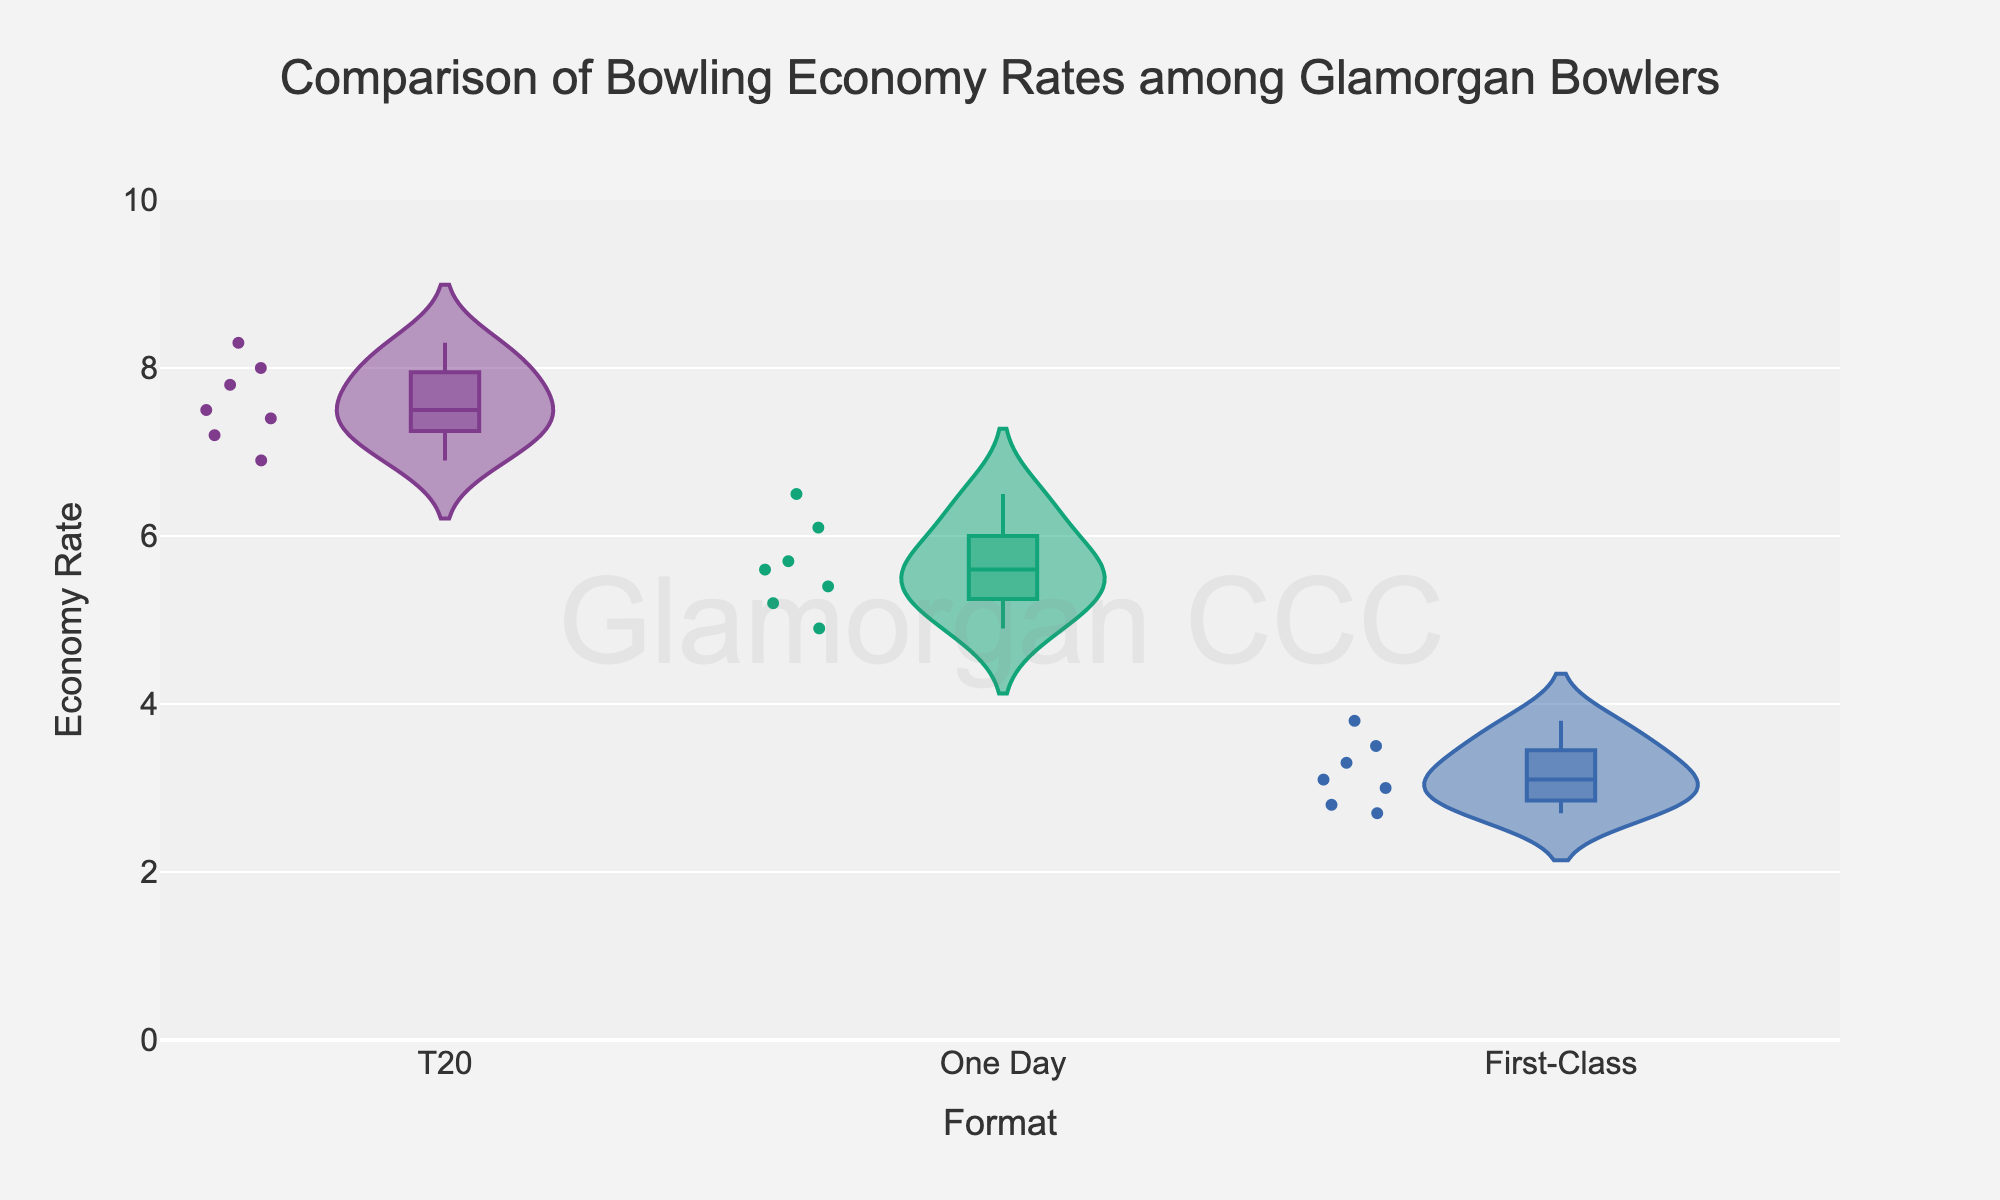Which formats are compared in the figure? The title and x-axis of the violin chart indicate the formats compared. The three formats are T20, One Day, and First-Class.
Answer: T20, One Day, First-Class What is the title of the chart? The title is located at the top of the chart in large font. It reads "Comparison of Bowling Economy Rates among Glamorgan Bowlers".
Answer: Comparison of Bowling Economy Rates among Glamorgan Bowlers Which format has the lowest economy rate among all bowlers? Look at the y-axis to see the economy rates and observe the distribution within each format's violin plot. The First-Class format has the lowest economy rates, with some values below 3.
Answer: First-Class What is the highest economy rate observed in T20? The topmost point on the T20 violin plot indicates the maximum economy rate. The highest economy rate in T20 is around 8.3.
Answer: 8.3 Which bowler has the lowest economy rate in One Day format? By hovering over the points and checking the hover data, the lowest economy rate in One Day is 4.9 by Andrew Salter.
Answer: Andrew Salter How does Andrew Salter's economy rate in T20 compare to his rate in First-Class? Andrew Salter's economy rate in T20 is 6.9, and in First-Class, it is 2.7. We subtract to compare: 6.9 - 2.7 = 4.2.
Answer: 4.2 higher in T20 What is the average economy rate for Michael Hogan across all formats? Add Michael Hogan's economy rates in T20 (7.2), One Day (5.4), and First-Class (2.8), then divide by 3. (7.2 + 5.4 + 2.8) / 3 ≈ 5.13.
Answer: 5.13 Which format shows the most variation in economy rates? The width and spread of the violin plots indicate variation. The T20 format's plot is wider and has more spread, suggesting the most variation.
Answer: T20 